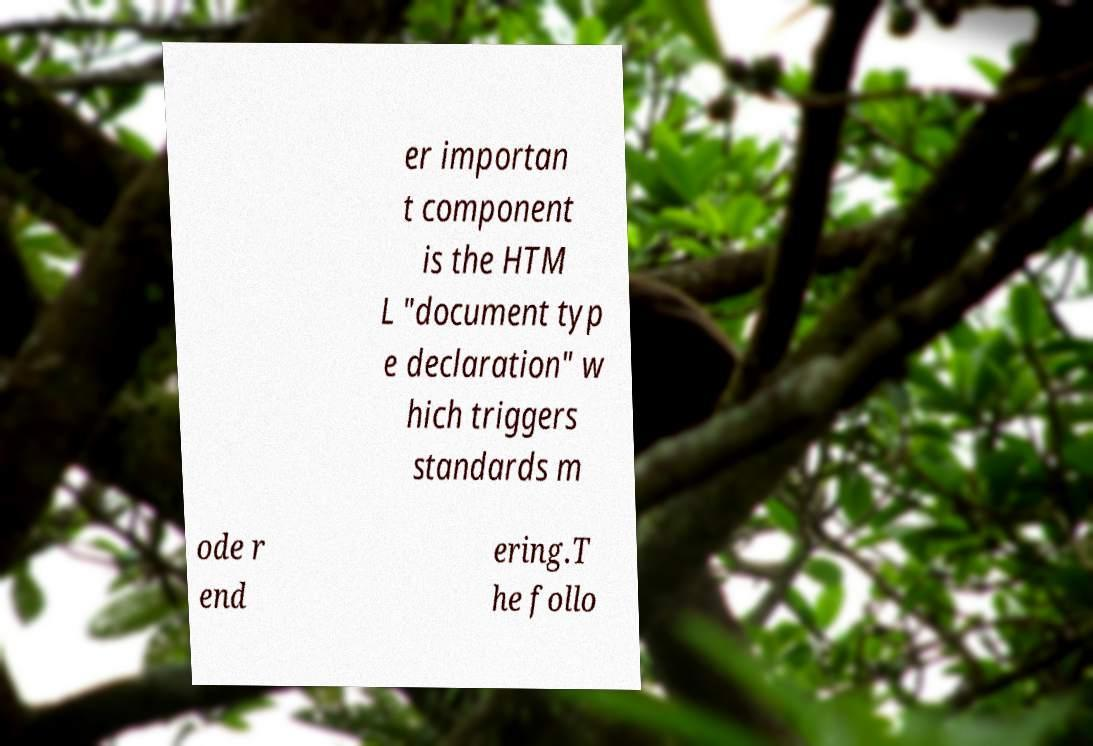Could you extract and type out the text from this image? er importan t component is the HTM L "document typ e declaration" w hich triggers standards m ode r end ering.T he follo 